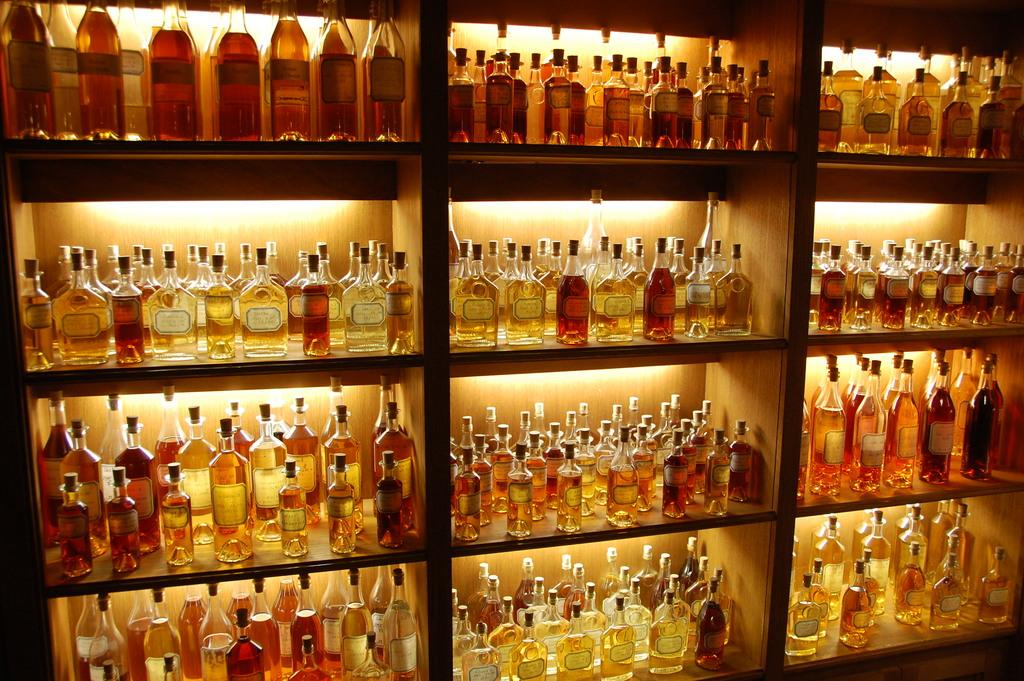What type of items are visible in the image? There are alcohol bottles in the image. Where are the alcohol bottles located? The alcohol bottles are placed on different shelves of a cupboard. What type of twig can be seen on the street in the image? There is no twig or street present in the image; it only features alcohol bottles on cupboard shelves. 